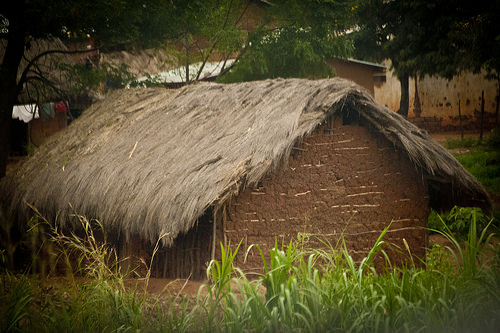<image>
Is the hut above the grass? Yes. The hut is positioned above the grass in the vertical space, higher up in the scene. Is there a weeds in front of the thatched roof? Yes. The weeds is positioned in front of the thatched roof, appearing closer to the camera viewpoint. 